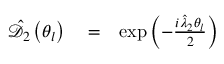Convert formula to latex. <formula><loc_0><loc_0><loc_500><loc_500>\begin{array} { r l r } { \hat { \mathcal { D } } _ { 2 } \left ( \theta _ { l } \right ) } & = } & { \exp \left ( - \frac { i \hat { \lambda } _ { 2 } \theta _ { l } } { 2 } \right ) } \end{array}</formula> 